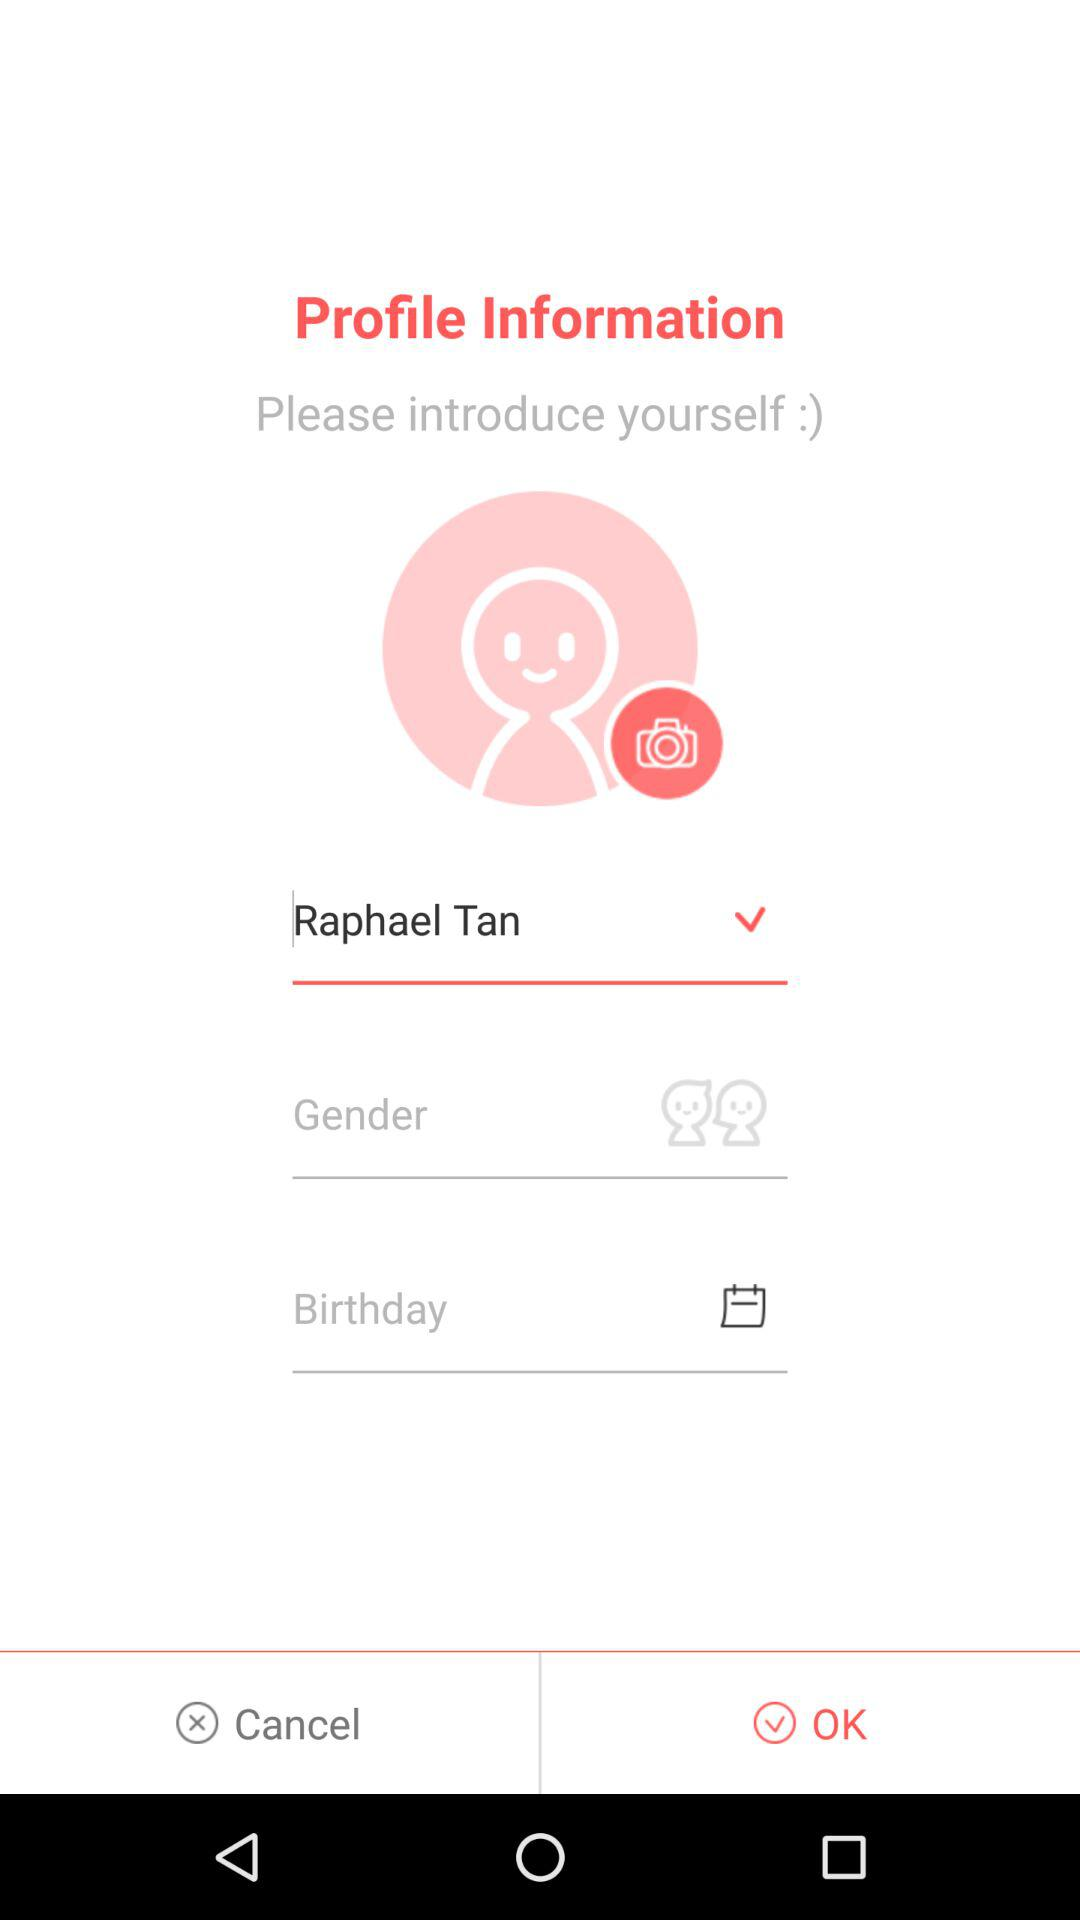What is the user name? The user name is Raphael Tan. 